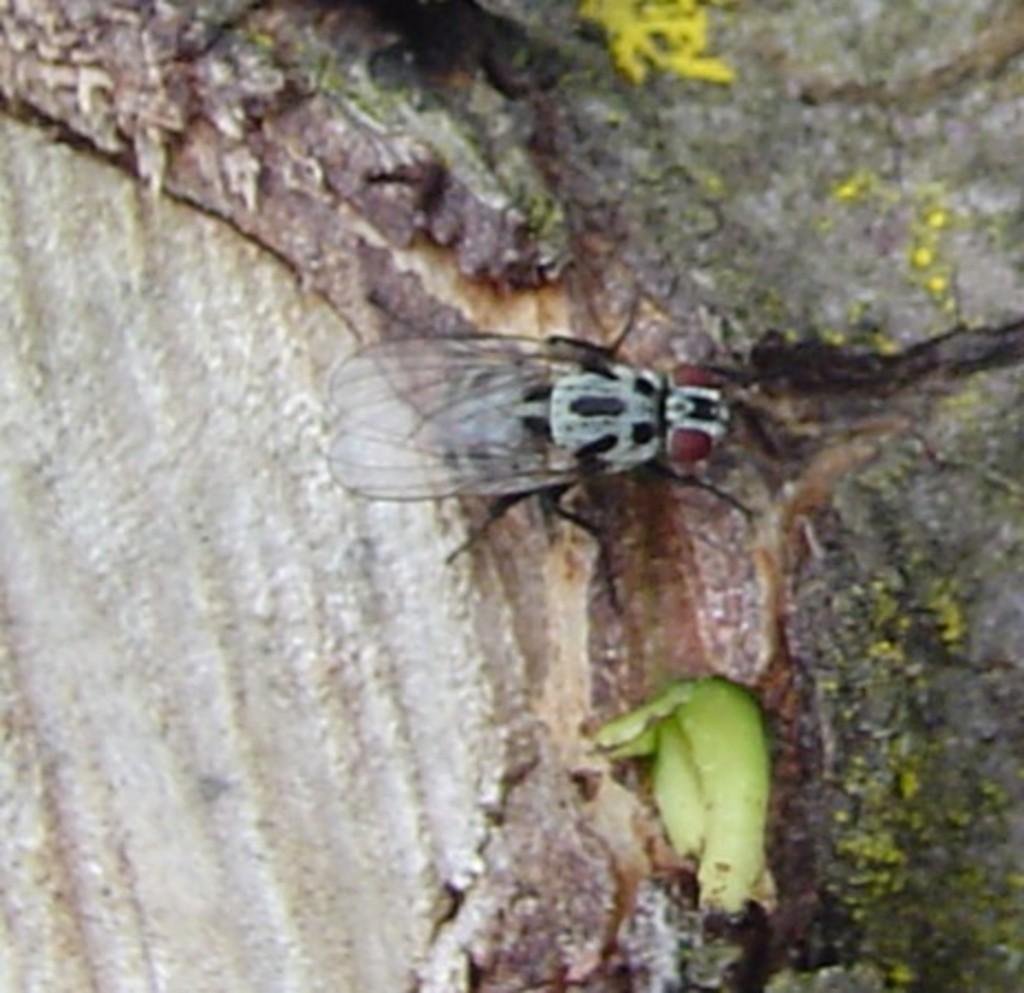Could you give a brief overview of what you see in this image? In this image in the center there is one housefly, and in the background there is a walkway. 